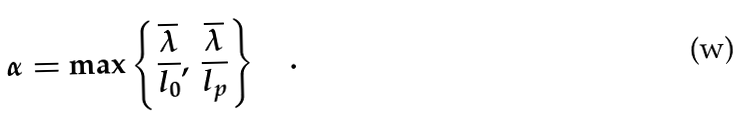<formula> <loc_0><loc_0><loc_500><loc_500>\alpha = \max \left \{ \frac { \overline { \lambda } } { l _ { 0 } } , \, \frac { \overline { \lambda } } { l _ { p } } \right \} \quad .</formula> 